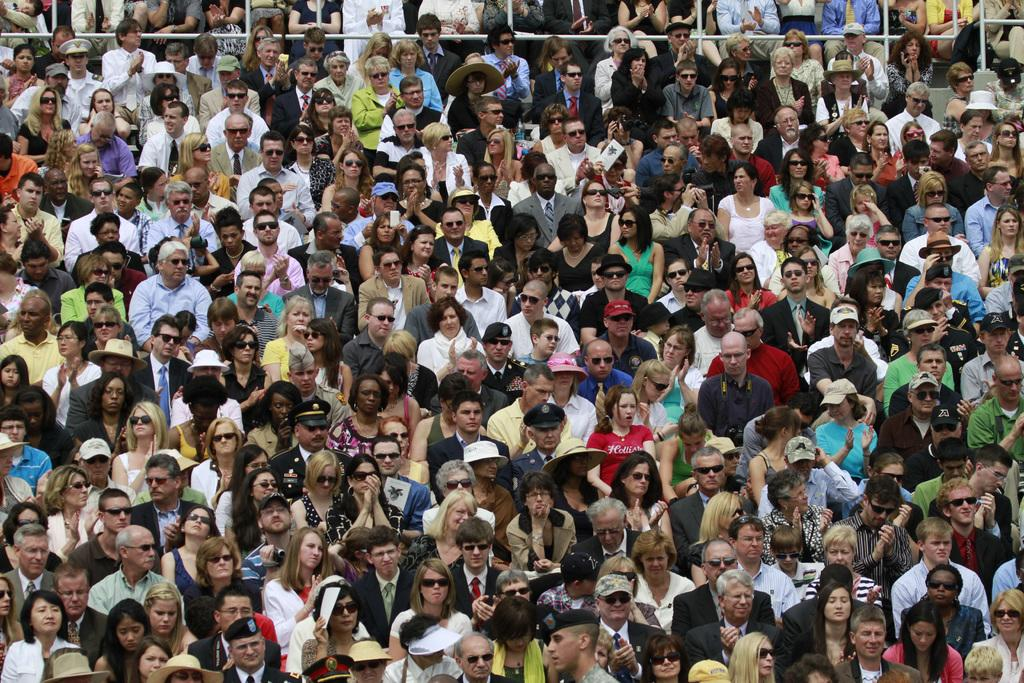How many individuals are present in the image? There is a group of people in the image. Can you describe the group's composition or activity? Unfortunately, the provided facts do not offer any additional information about the group's composition or activity. What color is the sister's hair in the image? There is no mention of a sister or hair color in the provided facts, so we cannot answer this question. 